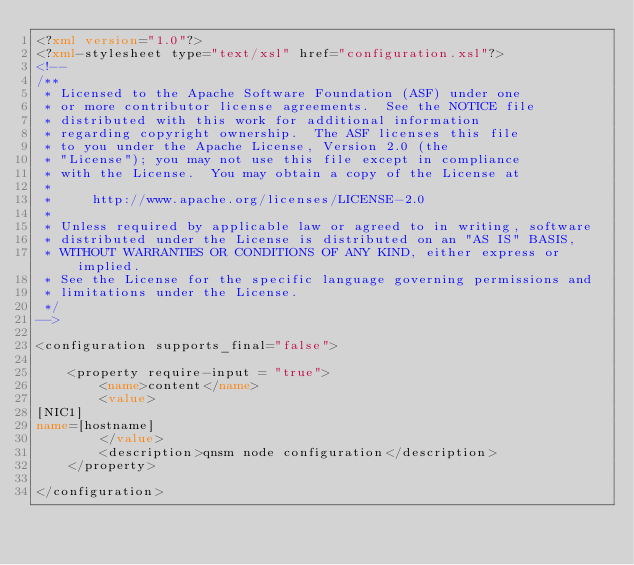<code> <loc_0><loc_0><loc_500><loc_500><_XML_><?xml version="1.0"?>
<?xml-stylesheet type="text/xsl" href="configuration.xsl"?>
<!--
/**
 * Licensed to the Apache Software Foundation (ASF) under one
 * or more contributor license agreements.  See the NOTICE file
 * distributed with this work for additional information
 * regarding copyright ownership.  The ASF licenses this file
 * to you under the Apache License, Version 2.0 (the
 * "License"); you may not use this file except in compliance
 * with the License.  You may obtain a copy of the License at
 *
 *     http://www.apache.org/licenses/LICENSE-2.0
 *
 * Unless required by applicable law or agreed to in writing, software
 * distributed under the License is distributed on an "AS IS" BASIS,
 * WITHOUT WARRANTIES OR CONDITIONS OF ANY KIND, either express or implied.
 * See the License for the specific language governing permissions and
 * limitations under the License.
 */
-->

<configuration supports_final="false">

    <property require-input = "true">
        <name>content</name>
        <value>
[NIC1]
name=[hostname]
        </value>
        <description>qnsm node configuration</description>
    </property>

</configuration></code> 